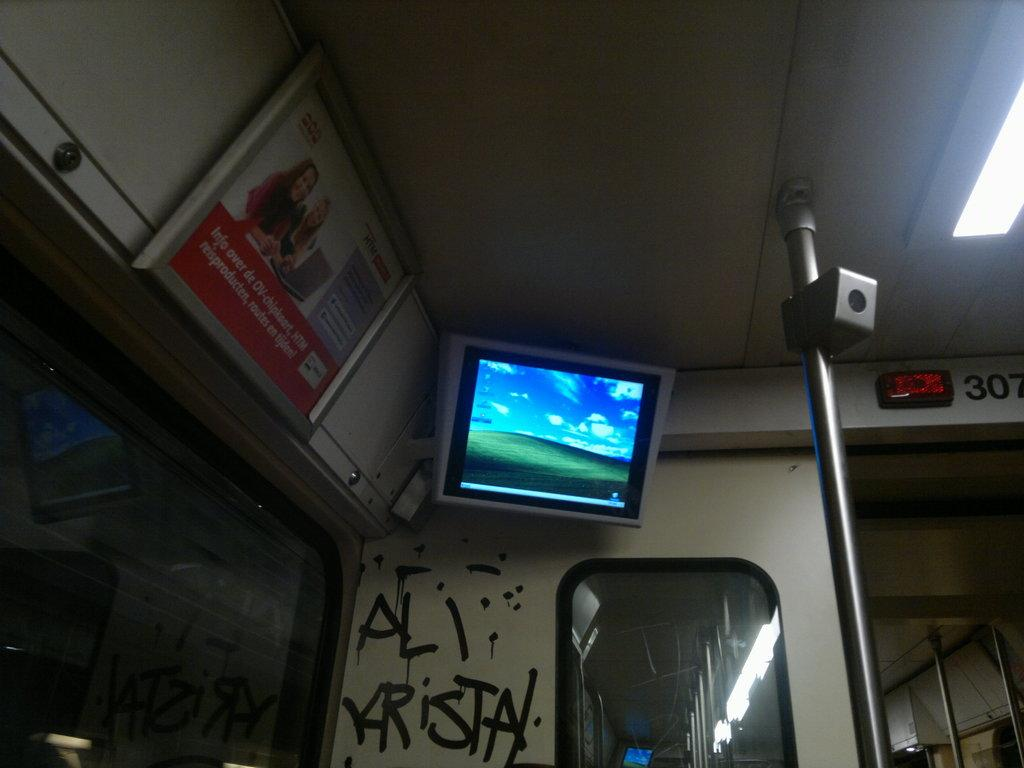<image>
Share a concise interpretation of the image provided. bus or train with a screen tv in the corner wall 